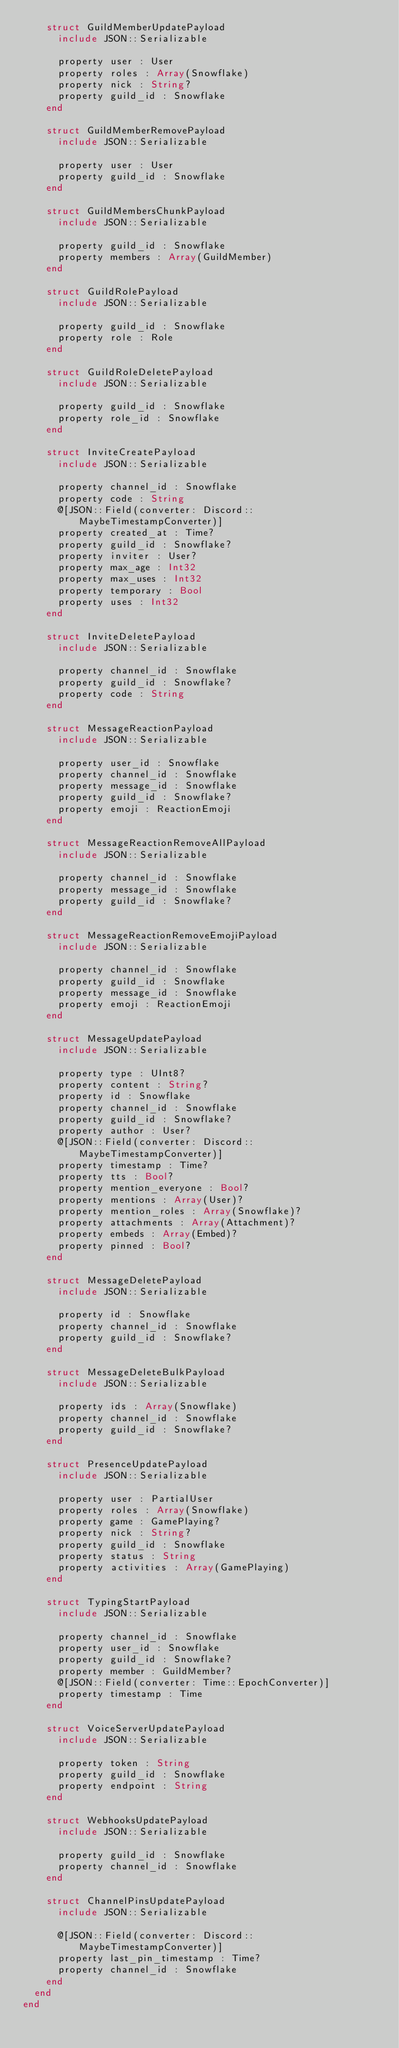<code> <loc_0><loc_0><loc_500><loc_500><_Crystal_>    struct GuildMemberUpdatePayload
      include JSON::Serializable

      property user : User
      property roles : Array(Snowflake)
      property nick : String?
      property guild_id : Snowflake
    end

    struct GuildMemberRemovePayload
      include JSON::Serializable

      property user : User
      property guild_id : Snowflake
    end

    struct GuildMembersChunkPayload
      include JSON::Serializable

      property guild_id : Snowflake
      property members : Array(GuildMember)
    end

    struct GuildRolePayload
      include JSON::Serializable

      property guild_id : Snowflake
      property role : Role
    end

    struct GuildRoleDeletePayload
      include JSON::Serializable

      property guild_id : Snowflake
      property role_id : Snowflake
    end

    struct InviteCreatePayload
      include JSON::Serializable

      property channel_id : Snowflake
      property code : String
      @[JSON::Field(converter: Discord::MaybeTimestampConverter)]
      property created_at : Time?
      property guild_id : Snowflake?
      property inviter : User?
      property max_age : Int32
      property max_uses : Int32
      property temporary : Bool
      property uses : Int32
    end

    struct InviteDeletePayload
      include JSON::Serializable

      property channel_id : Snowflake
      property guild_id : Snowflake?
      property code : String
    end

    struct MessageReactionPayload
      include JSON::Serializable

      property user_id : Snowflake
      property channel_id : Snowflake
      property message_id : Snowflake
      property guild_id : Snowflake?
      property emoji : ReactionEmoji
    end

    struct MessageReactionRemoveAllPayload
      include JSON::Serializable

      property channel_id : Snowflake
      property message_id : Snowflake
      property guild_id : Snowflake?
    end

    struct MessageReactionRemoveEmojiPayload
      include JSON::Serializable

      property channel_id : Snowflake
      property guild_id : Snowflake
      property message_id : Snowflake
      property emoji : ReactionEmoji
    end

    struct MessageUpdatePayload
      include JSON::Serializable

      property type : UInt8?
      property content : String?
      property id : Snowflake
      property channel_id : Snowflake
      property guild_id : Snowflake?
      property author : User?
      @[JSON::Field(converter: Discord::MaybeTimestampConverter)]
      property timestamp : Time?
      property tts : Bool?
      property mention_everyone : Bool?
      property mentions : Array(User)?
      property mention_roles : Array(Snowflake)?
      property attachments : Array(Attachment)?
      property embeds : Array(Embed)?
      property pinned : Bool?
    end

    struct MessageDeletePayload
      include JSON::Serializable

      property id : Snowflake
      property channel_id : Snowflake
      property guild_id : Snowflake?
    end

    struct MessageDeleteBulkPayload
      include JSON::Serializable

      property ids : Array(Snowflake)
      property channel_id : Snowflake
      property guild_id : Snowflake?
    end

    struct PresenceUpdatePayload
      include JSON::Serializable

      property user : PartialUser
      property roles : Array(Snowflake)
      property game : GamePlaying?
      property nick : String?
      property guild_id : Snowflake
      property status : String
      property activities : Array(GamePlaying)
    end

    struct TypingStartPayload
      include JSON::Serializable

      property channel_id : Snowflake
      property user_id : Snowflake
      property guild_id : Snowflake?
      property member : GuildMember?
      @[JSON::Field(converter: Time::EpochConverter)]
      property timestamp : Time
    end

    struct VoiceServerUpdatePayload
      include JSON::Serializable

      property token : String
      property guild_id : Snowflake
      property endpoint : String
    end

    struct WebhooksUpdatePayload
      include JSON::Serializable

      property guild_id : Snowflake
      property channel_id : Snowflake
    end

    struct ChannelPinsUpdatePayload
      include JSON::Serializable

      @[JSON::Field(converter: Discord::MaybeTimestampConverter)]
      property last_pin_timestamp : Time?
      property channel_id : Snowflake
    end
  end
end
</code> 